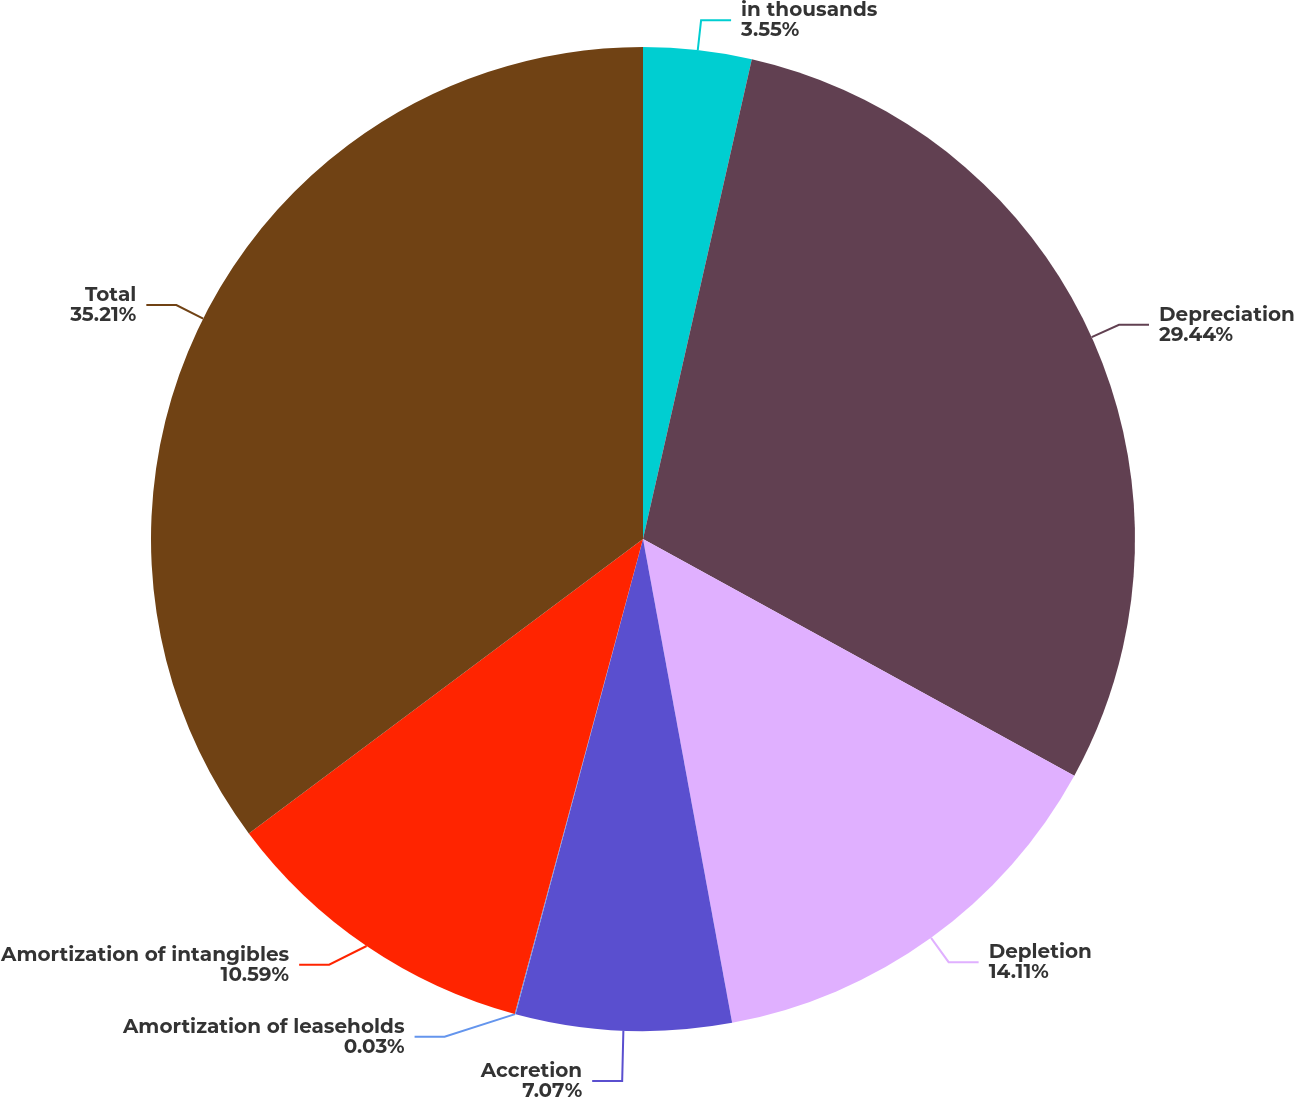Convert chart. <chart><loc_0><loc_0><loc_500><loc_500><pie_chart><fcel>in thousands<fcel>Depreciation<fcel>Depletion<fcel>Accretion<fcel>Amortization of leaseholds<fcel>Amortization of intangibles<fcel>Total<nl><fcel>3.55%<fcel>29.44%<fcel>14.11%<fcel>7.07%<fcel>0.03%<fcel>10.59%<fcel>35.21%<nl></chart> 